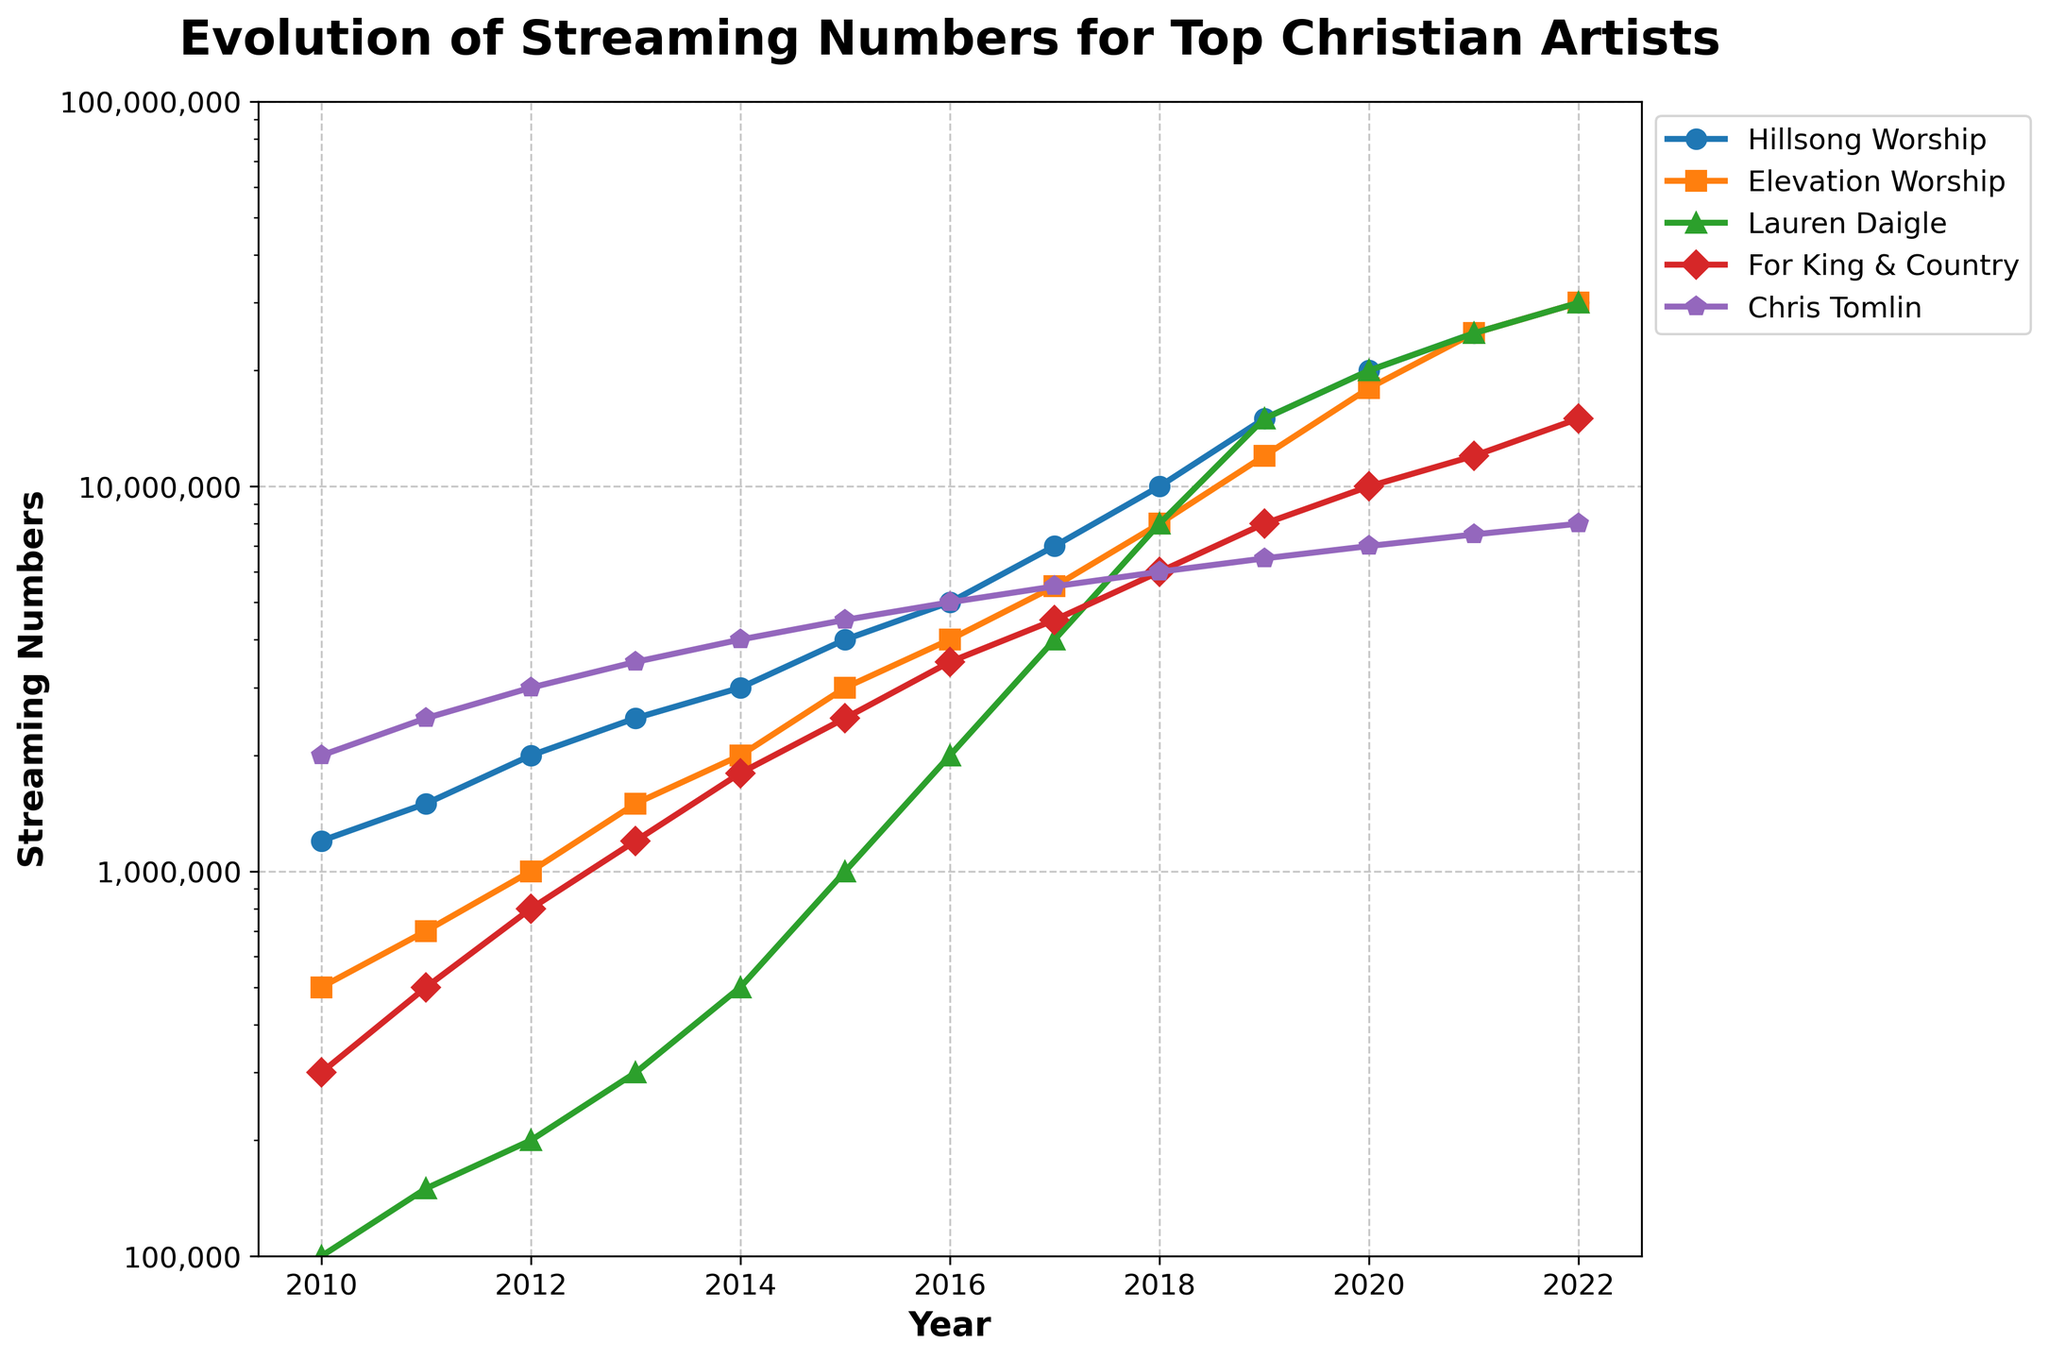What's the overall trend for Hillsong Worship's streaming numbers since 2010? The trend is a consistent increase. Hillsong Worship started with 1,200,000 streams in 2010 and reached 30,000,000 streams by 2022, showing continuous and significant growth over the observed period.
Answer: Consistently increasing Which artist had the highest streaming numbers in 2022? From the figure, all three artists—Hillsong Worship, Elevation Worship, and Lauren Daigle—each reached 30,000,000 streams in 2022.
Answer: Hillsong Worship, Elevation Worship, and Lauren Daigle How did Lauren Daigle's streaming numbers compare to For King & Country's in 2019? In 2019, Lauren Daigle had 15,000,000 streams, while For King & Country had 8,000,000 streams, indicating that Lauren Daigle's numbers were significantly higher.
Answer: Higher How much did Chris Tomlin's streaming numbers increase from 2010 to 2020? Chris Tomlin's streams were 2,000,000 in 2010 and grew to 7,000,000 by 2020. The increase is computed as 7,000,000 - 2,000,000 = 5,000,000.
Answer: 5,000,000 What was the average streaming number for Elevation Worship between 2016 and 2022? Elevation Worship's streaming numbers from 2016 to 2022 are 4,000,000, 5,500,000, 8,000,000, 12,000,000, 18,000,000, 25,000,000, and 30,000,000. The average is (4,000,000 + 5,500,000 + 8,000,000 + 12,000,000 + 18,000,000 + 25,000,000 + 30,000,000) / 7 = 14,214,286 approximately.
Answer: 14,214,286 In which year did For King & Country's streaming numbers first exceed 5,000,000? For King & Country's streaming numbers first exceeded 5,000,000 in 2018, where they had 6,000,000 streams.
Answer: 2018 What's the combined streaming total for all five artists in 2021? The total streaming numbers in 2021 for all five artists are: 25,000,000 (Hillsong Worship) + 25,000,000 (Elevation Worship) + 25,000,000 (Lauren Daigle) + 12,000,000 (For King & Country) + 7,500,000 (Chris Tomlin) = 94,500,000.
Answer: 94,500,000 By how much did Elevation Worship’s streaming numbers increase between 2015 and 2020? Elevation Worship’s streaming numbers in 2015 were 3,000,000 and increased to 18,000,000 by 2020. The increase is 18,000,000 - 3,000,000 = 15,000,000.
Answer: 15,000,000 When did Lauren Daigle's streaming numbers reach 20,000,000? Lauren Daigle’s streaming numbers reached 20,000,000 in 2020.
Answer: 2020 